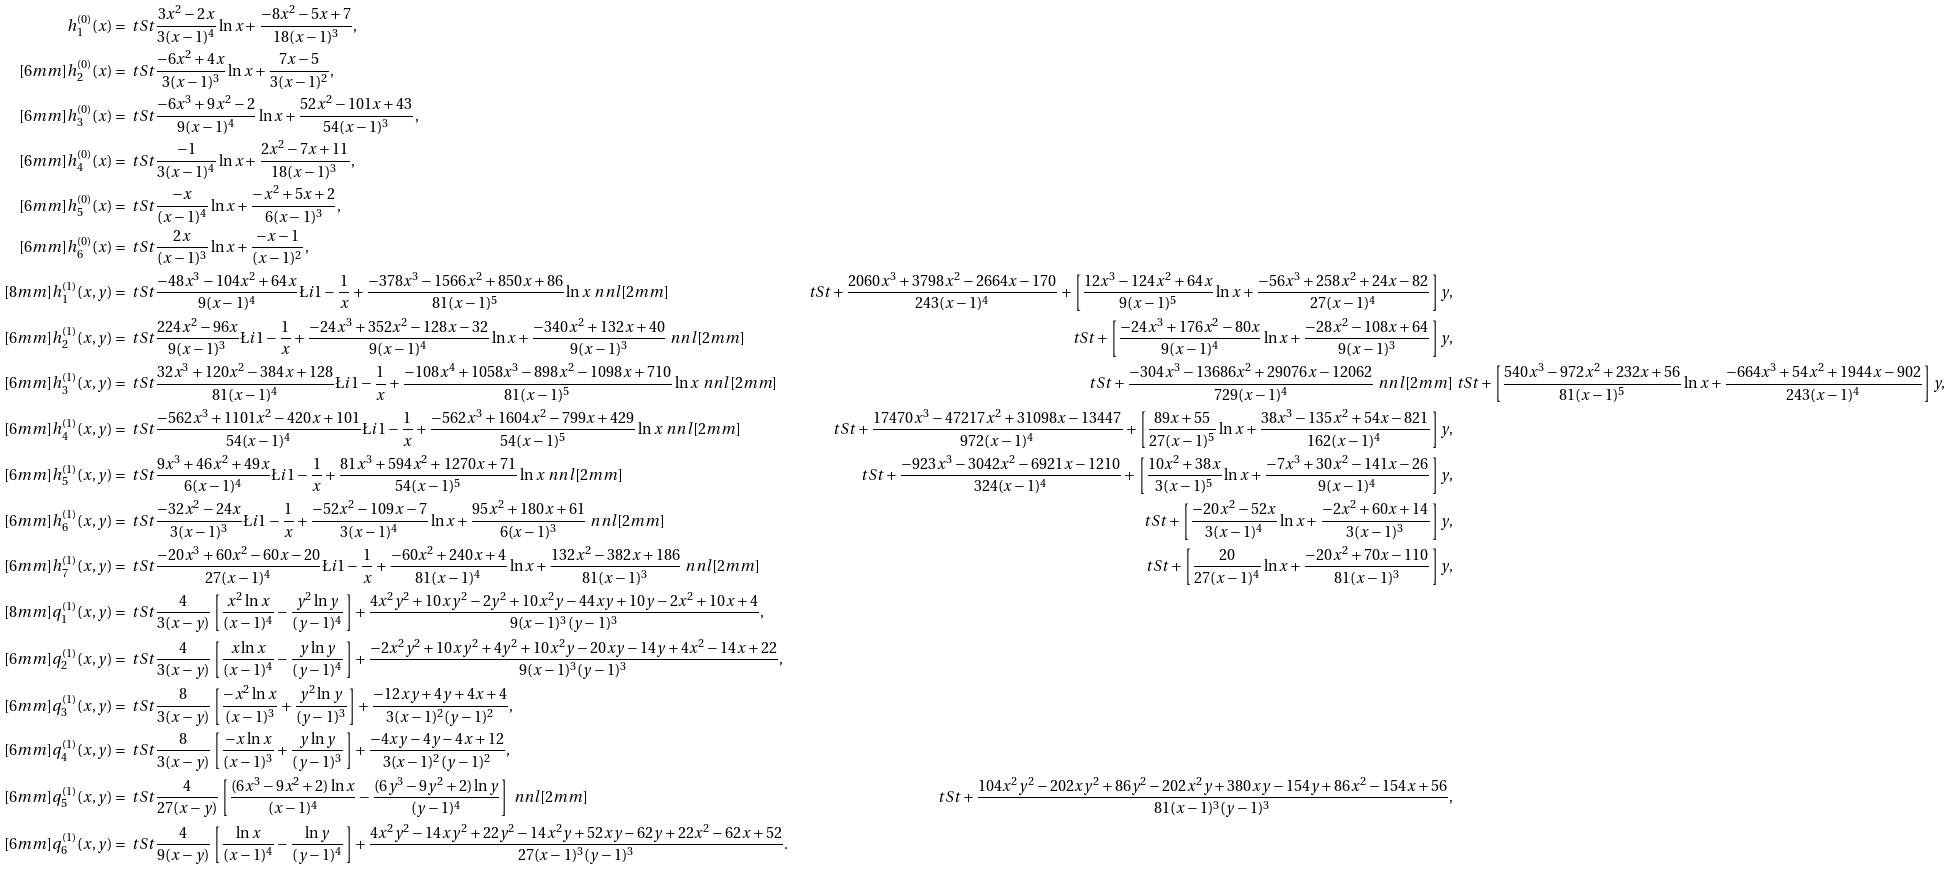<formula> <loc_0><loc_0><loc_500><loc_500>h _ { 1 } ^ { ( 0 ) } ( x ) & = \ t S t \frac { 3 x ^ { 2 } - 2 x } { 3 ( x - 1 ) ^ { 4 } } \ln x + \frac { - 8 x ^ { 2 } - 5 x + 7 } { 1 8 ( x - 1 ) ^ { 3 } } , \\ [ 6 m m ] h _ { 2 } ^ { ( 0 ) } ( x ) & = \ t S t \frac { - 6 x ^ { 2 } + 4 x } { 3 ( x - 1 ) ^ { 3 } } \ln x + \frac { 7 x - 5 } { 3 ( x - 1 ) ^ { 2 } } , \\ [ 6 m m ] h _ { 3 } ^ { ( 0 ) } ( x ) & = \ t S t \frac { - 6 x ^ { 3 } + 9 x ^ { 2 } - 2 } { 9 ( x - 1 ) ^ { 4 } } \ln x + \frac { 5 2 x ^ { 2 } - 1 0 1 x + 4 3 } { 5 4 ( x - 1 ) ^ { 3 } } , \\ [ 6 m m ] h _ { 4 } ^ { ( 0 ) } ( x ) & = \ t S t \frac { - 1 } { 3 ( x - 1 ) ^ { 4 } } \ln x + \frac { 2 x ^ { 2 } - 7 x + 1 1 } { 1 8 ( x - 1 ) ^ { 3 } } , \\ [ 6 m m ] h _ { 5 } ^ { ( 0 ) } ( x ) & = \ t S t \frac { - x } { ( x - 1 ) ^ { 4 } } \ln x + \frac { - x ^ { 2 } + 5 x + 2 } { 6 ( x - 1 ) ^ { 3 } } , \\ [ 6 m m ] h _ { 6 } ^ { ( 0 ) } ( x ) & = \ t S t \frac { 2 x } { ( x - 1 ) ^ { 3 } } \ln x + \frac { - x - 1 } { ( x - 1 ) ^ { 2 } } , \\ [ 8 m m ] h _ { 1 } ^ { ( 1 ) } ( x , y ) & = \ t S t \frac { - 4 8 x ^ { 3 } - 1 0 4 x ^ { 2 } + 6 4 x } { 9 ( x - 1 ) ^ { 4 } } \L i { 1 - \frac { 1 } { x } } + \frac { - 3 7 8 x ^ { 3 } - 1 5 6 6 x ^ { 2 } + 8 5 0 x + 8 6 } { 8 1 ( x - 1 ) ^ { 5 } } \ln x \ n n l [ 2 m m ] & \ t S t + \frac { 2 0 6 0 x ^ { 3 } + 3 7 9 8 x ^ { 2 } - 2 6 6 4 x - 1 7 0 } { 2 4 3 ( x - 1 ) ^ { 4 } } + \left [ \frac { 1 2 x ^ { 3 } - 1 2 4 x ^ { 2 } + 6 4 x } { 9 ( x - 1 ) ^ { 5 } } \ln x + \frac { - 5 6 x ^ { 3 } + 2 5 8 x ^ { 2 } + 2 4 x - 8 2 } { 2 7 ( x - 1 ) ^ { 4 } } \right ] y , \\ [ 6 m m ] h _ { 2 } ^ { ( 1 ) } ( x , y ) & = \ t S t \frac { 2 2 4 x ^ { 2 } - 9 6 x } { 9 ( x - 1 ) ^ { 3 } } \L i { 1 - \frac { 1 } { x } } + \frac { - 2 4 x ^ { 3 } + 3 5 2 x ^ { 2 } - 1 2 8 x - 3 2 } { 9 ( x - 1 ) ^ { 4 } } \ln x + \frac { - 3 4 0 x ^ { 2 } + 1 3 2 x + 4 0 } { 9 ( x - 1 ) ^ { 3 } } \ n n l [ 2 m m ] & \ t S t + \left [ \frac { - 2 4 x ^ { 3 } + 1 7 6 x ^ { 2 } - 8 0 x } { 9 ( x - 1 ) ^ { 4 } } \ln x + \frac { - 2 8 x ^ { 2 } - 1 0 8 x + 6 4 } { 9 ( x - 1 ) ^ { 3 } } \right ] y , \\ [ 6 m m ] h _ { 3 } ^ { ( 1 ) } ( x , y ) & = \ t S t \frac { 3 2 x ^ { 3 } + 1 2 0 x ^ { 2 } - 3 8 4 x + 1 2 8 } { 8 1 ( x - 1 ) ^ { 4 } } \L i { 1 - \frac { 1 } { x } } + \frac { - 1 0 8 x ^ { 4 } + 1 0 5 8 x ^ { 3 } - 8 9 8 x ^ { 2 } - 1 0 9 8 x + 7 1 0 } { 8 1 ( x - 1 ) ^ { 5 } } \ln x \ n n l [ 2 m m ] & \ t S t + \frac { - 3 0 4 x ^ { 3 } - 1 3 6 8 6 x ^ { 2 } + 2 9 0 7 6 x - 1 2 0 6 2 } { 7 2 9 ( x - 1 ) ^ { 4 } } \ n n l [ 2 m m ] & \ t S t + \left [ \frac { 5 4 0 x ^ { 3 } - 9 7 2 x ^ { 2 } + 2 3 2 x + 5 6 } { 8 1 ( x - 1 ) ^ { 5 } } \ln x + \frac { - 6 6 4 x ^ { 3 } + 5 4 x ^ { 2 } + 1 9 4 4 x - 9 0 2 } { 2 4 3 ( x - 1 ) ^ { 4 } } \right ] y , \\ [ 6 m m ] h _ { 4 } ^ { ( 1 ) } ( x , y ) & = \ t S t \frac { - 5 6 2 x ^ { 3 } + 1 1 0 1 x ^ { 2 } - 4 2 0 x + 1 0 1 } { 5 4 ( x - 1 ) ^ { 4 } } \L i { 1 - \frac { 1 } { x } } + \frac { - 5 6 2 x ^ { 3 } + 1 6 0 4 x ^ { 2 } - 7 9 9 x + 4 2 9 } { 5 4 ( x - 1 ) ^ { 5 } } \ln x \ n n l [ 2 m m ] & \ t S t + \frac { 1 7 4 7 0 x ^ { 3 } - 4 7 2 1 7 x ^ { 2 } + 3 1 0 9 8 x - 1 3 4 4 7 } { 9 7 2 ( x - 1 ) ^ { 4 } } + \left [ \frac { 8 9 x + 5 5 } { 2 7 ( x - 1 ) ^ { 5 } } \ln x + \frac { 3 8 x ^ { 3 } - 1 3 5 x ^ { 2 } + 5 4 x - 8 2 1 } { 1 6 2 ( x - 1 ) ^ { 4 } } \right ] y , \\ [ 6 m m ] h _ { 5 } ^ { ( 1 ) } ( x , y ) & = \ t S t \frac { 9 x ^ { 3 } + 4 6 x ^ { 2 } + 4 9 x } { 6 ( x - 1 ) ^ { 4 } } \L i { 1 - \frac { 1 } { x } } + \frac { 8 1 x ^ { 3 } + 5 9 4 x ^ { 2 } + 1 2 7 0 x + 7 1 } { 5 4 ( x - 1 ) ^ { 5 } } \ln x \ n n l [ 2 m m ] & \ t S t + \frac { - 9 2 3 x ^ { 3 } - 3 0 4 2 x ^ { 2 } - 6 9 2 1 x - 1 2 1 0 } { 3 2 4 ( x - 1 ) ^ { 4 } } + \left [ \frac { 1 0 x ^ { 2 } + 3 8 x } { 3 ( x - 1 ) ^ { 5 } } \ln x + \frac { - 7 x ^ { 3 } + 3 0 x ^ { 2 } - 1 4 1 x - 2 6 } { 9 ( x - 1 ) ^ { 4 } } \right ] y , \\ [ 6 m m ] h _ { 6 } ^ { ( 1 ) } ( x , y ) & = \ t S t \frac { - 3 2 x ^ { 2 } - 2 4 x } { 3 ( x - 1 ) ^ { 3 } } \L i { 1 - \frac { 1 } { x } } + \frac { - 5 2 x ^ { 2 } - 1 0 9 x - 7 } { 3 ( x - 1 ) ^ { 4 } } \ln x + \frac { 9 5 x ^ { 2 } + 1 8 0 x + 6 1 } { 6 ( x - 1 ) ^ { 3 } } \ n n l [ 2 m m ] & \ t S t + \left [ \frac { - 2 0 x ^ { 2 } - 5 2 x } { 3 ( x - 1 ) ^ { 4 } } \ln x + \frac { - 2 x ^ { 2 } + 6 0 x + 1 4 } { 3 ( x - 1 ) ^ { 3 } } \right ] y , \\ [ 6 m m ] h _ { 7 } ^ { ( 1 ) } ( x , y ) & = \ t S t \frac { - 2 0 x ^ { 3 } + 6 0 x ^ { 2 } - 6 0 x - 2 0 } { 2 7 ( x - 1 ) ^ { 4 } } \L i { 1 - \frac { 1 } { x } } + \frac { - 6 0 x ^ { 2 } + 2 4 0 x + 4 } { 8 1 ( x - 1 ) ^ { 4 } } \ln x + \frac { 1 3 2 x ^ { 2 } - 3 8 2 x + 1 8 6 } { 8 1 ( x - 1 ) ^ { 3 } } \ n n l [ 2 m m ] & \ t S t + \left [ \frac { 2 0 } { 2 7 ( x - 1 ) ^ { 4 } } \ln x + \frac { - 2 0 x ^ { 2 } + 7 0 x - 1 1 0 } { 8 1 ( x - 1 ) ^ { 3 } } \right ] y , \\ [ 8 m m ] q _ { 1 } ^ { ( 1 ) } ( x , y ) & = \ t S t \frac { 4 } { 3 ( x - y ) } \left [ \frac { x ^ { 2 } \ln x } { ( x - 1 ) ^ { 4 } } - \frac { y ^ { 2 } \ln y } { ( y - 1 ) ^ { 4 } } \right ] + \frac { 4 x ^ { 2 } y ^ { 2 } + 1 0 x y ^ { 2 } - 2 y ^ { 2 } + 1 0 x ^ { 2 } y - 4 4 x y + 1 0 y - 2 x ^ { 2 } + 1 0 x + 4 } { 9 ( x - 1 ) ^ { 3 } ( y - 1 ) ^ { 3 } } , \\ [ 6 m m ] q _ { 2 } ^ { ( 1 ) } ( x , y ) & = \ t S t \frac { 4 } { 3 ( x - y ) } \left [ \frac { x \ln x } { ( x - 1 ) ^ { 4 } } - \frac { y \ln y } { ( y - 1 ) ^ { 4 } } \right ] + \frac { - 2 x ^ { 2 } y ^ { 2 } + 1 0 x y ^ { 2 } + 4 y ^ { 2 } + 1 0 x ^ { 2 } y - 2 0 x y - 1 4 y + 4 x ^ { 2 } - 1 4 x + 2 2 } { 9 ( x - 1 ) ^ { 3 } ( y - 1 ) ^ { 3 } } , \\ [ 6 m m ] q _ { 3 } ^ { ( 1 ) } ( x , y ) & = \ t S t \frac { 8 } { 3 ( x - y ) } \left [ \frac { - x ^ { 2 } \ln x } { ( x - 1 ) ^ { 3 } } + \frac { y ^ { 2 } \ln y } { ( y - 1 ) ^ { 3 } } \right ] + \frac { - 1 2 x y + 4 y + 4 x + 4 } { 3 ( x - 1 ) ^ { 2 } ( y - 1 ) ^ { 2 } } , \\ [ 6 m m ] q _ { 4 } ^ { ( 1 ) } ( x , y ) & = \ t S t \frac { 8 } { 3 ( x - y ) } \left [ \frac { - x \ln x } { ( x - 1 ) ^ { 3 } } + \frac { y \ln y } { ( y - 1 ) ^ { 3 } } \right ] + \frac { - 4 x y - 4 y - 4 x + 1 2 } { 3 ( x - 1 ) ^ { 2 } ( y - 1 ) ^ { 2 } } , \\ [ 6 m m ] q _ { 5 } ^ { ( 1 ) } ( x , y ) & = \ t S t \frac { 4 } { 2 7 ( x - y ) } \left [ \frac { ( 6 x ^ { 3 } - 9 x ^ { 2 } + 2 ) \ln x } { ( x - 1 ) ^ { 4 } } - \frac { ( 6 y ^ { 3 } - 9 y ^ { 2 } + 2 ) \ln y } { ( y - 1 ) ^ { 4 } } \right ] \ n n l [ 2 m m ] & \ t S t + \frac { 1 0 4 x ^ { 2 } y ^ { 2 } - 2 0 2 x y ^ { 2 } + 8 6 y ^ { 2 } - 2 0 2 x ^ { 2 } y + 3 8 0 x y - 1 5 4 y + 8 6 x ^ { 2 } - 1 5 4 x + 5 6 } { 8 1 ( x - 1 ) ^ { 3 } ( y - 1 ) ^ { 3 } } , \\ [ 6 m m ] q _ { 6 } ^ { ( 1 ) } ( x , y ) & = \ t S t \frac { 4 } { 9 ( x - y ) } \left [ \frac { \ln x } { ( x - 1 ) ^ { 4 } } - \frac { \ln y } { ( y - 1 ) ^ { 4 } } \right ] + \frac { 4 x ^ { 2 } y ^ { 2 } - 1 4 x y ^ { 2 } + 2 2 y ^ { 2 } - 1 4 x ^ { 2 } y + 5 2 x y - 6 2 y + 2 2 x ^ { 2 } - 6 2 x + 5 2 } { 2 7 ( x - 1 ) ^ { 3 } ( y - 1 ) ^ { 3 } } .</formula> 